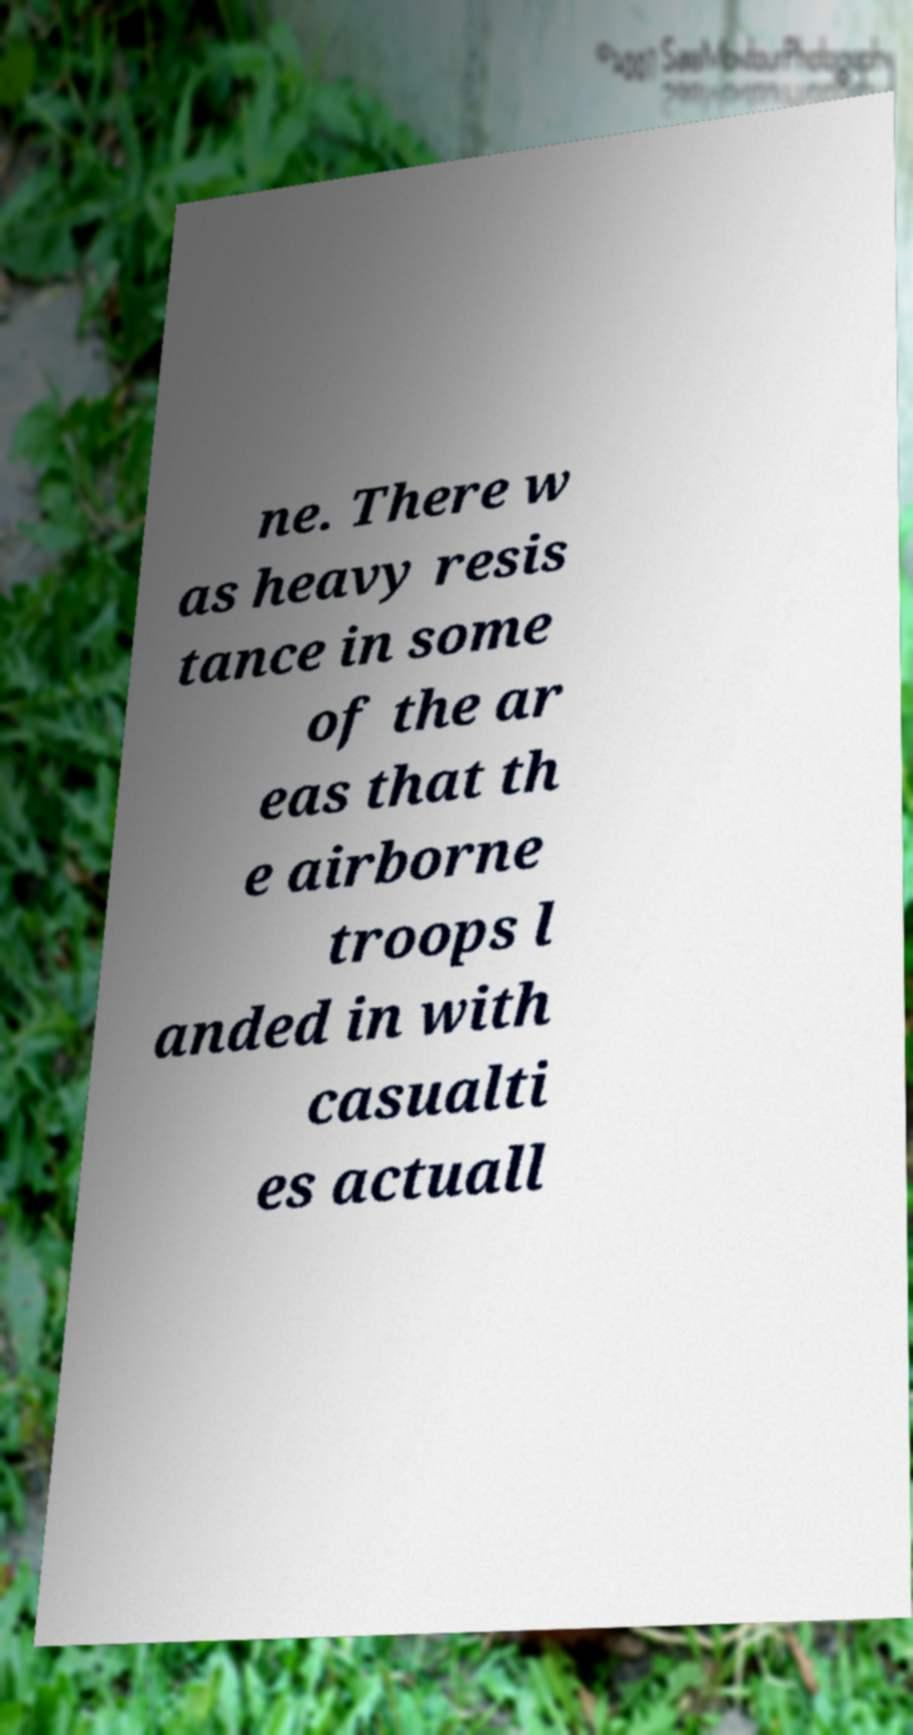I need the written content from this picture converted into text. Can you do that? ne. There w as heavy resis tance in some of the ar eas that th e airborne troops l anded in with casualti es actuall 